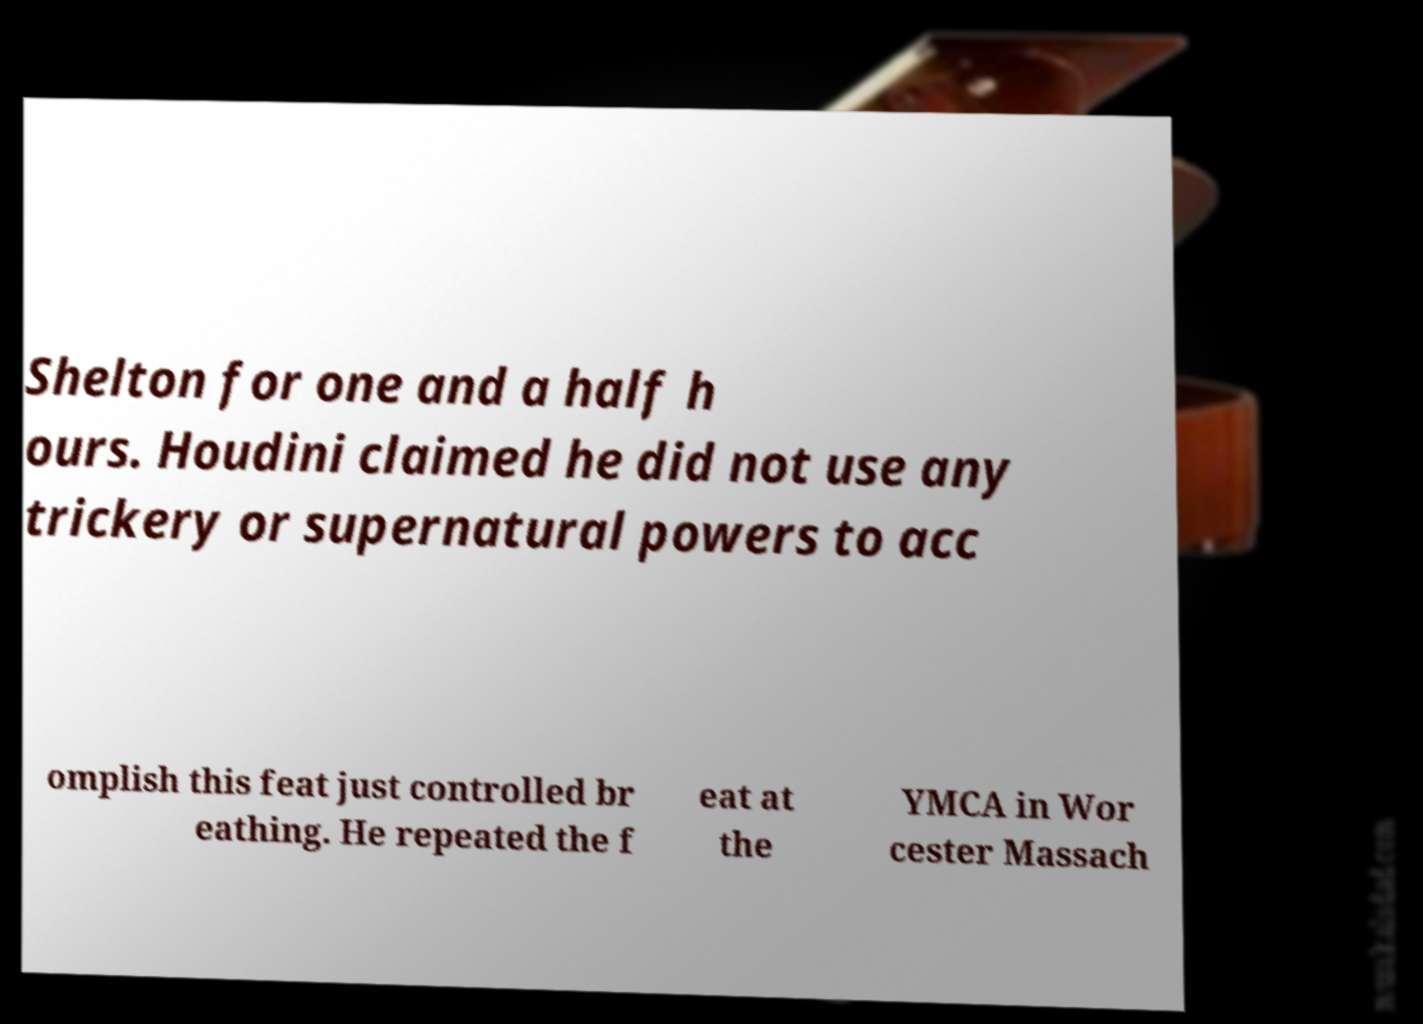Can you accurately transcribe the text from the provided image for me? Shelton for one and a half h ours. Houdini claimed he did not use any trickery or supernatural powers to acc omplish this feat just controlled br eathing. He repeated the f eat at the YMCA in Wor cester Massach 